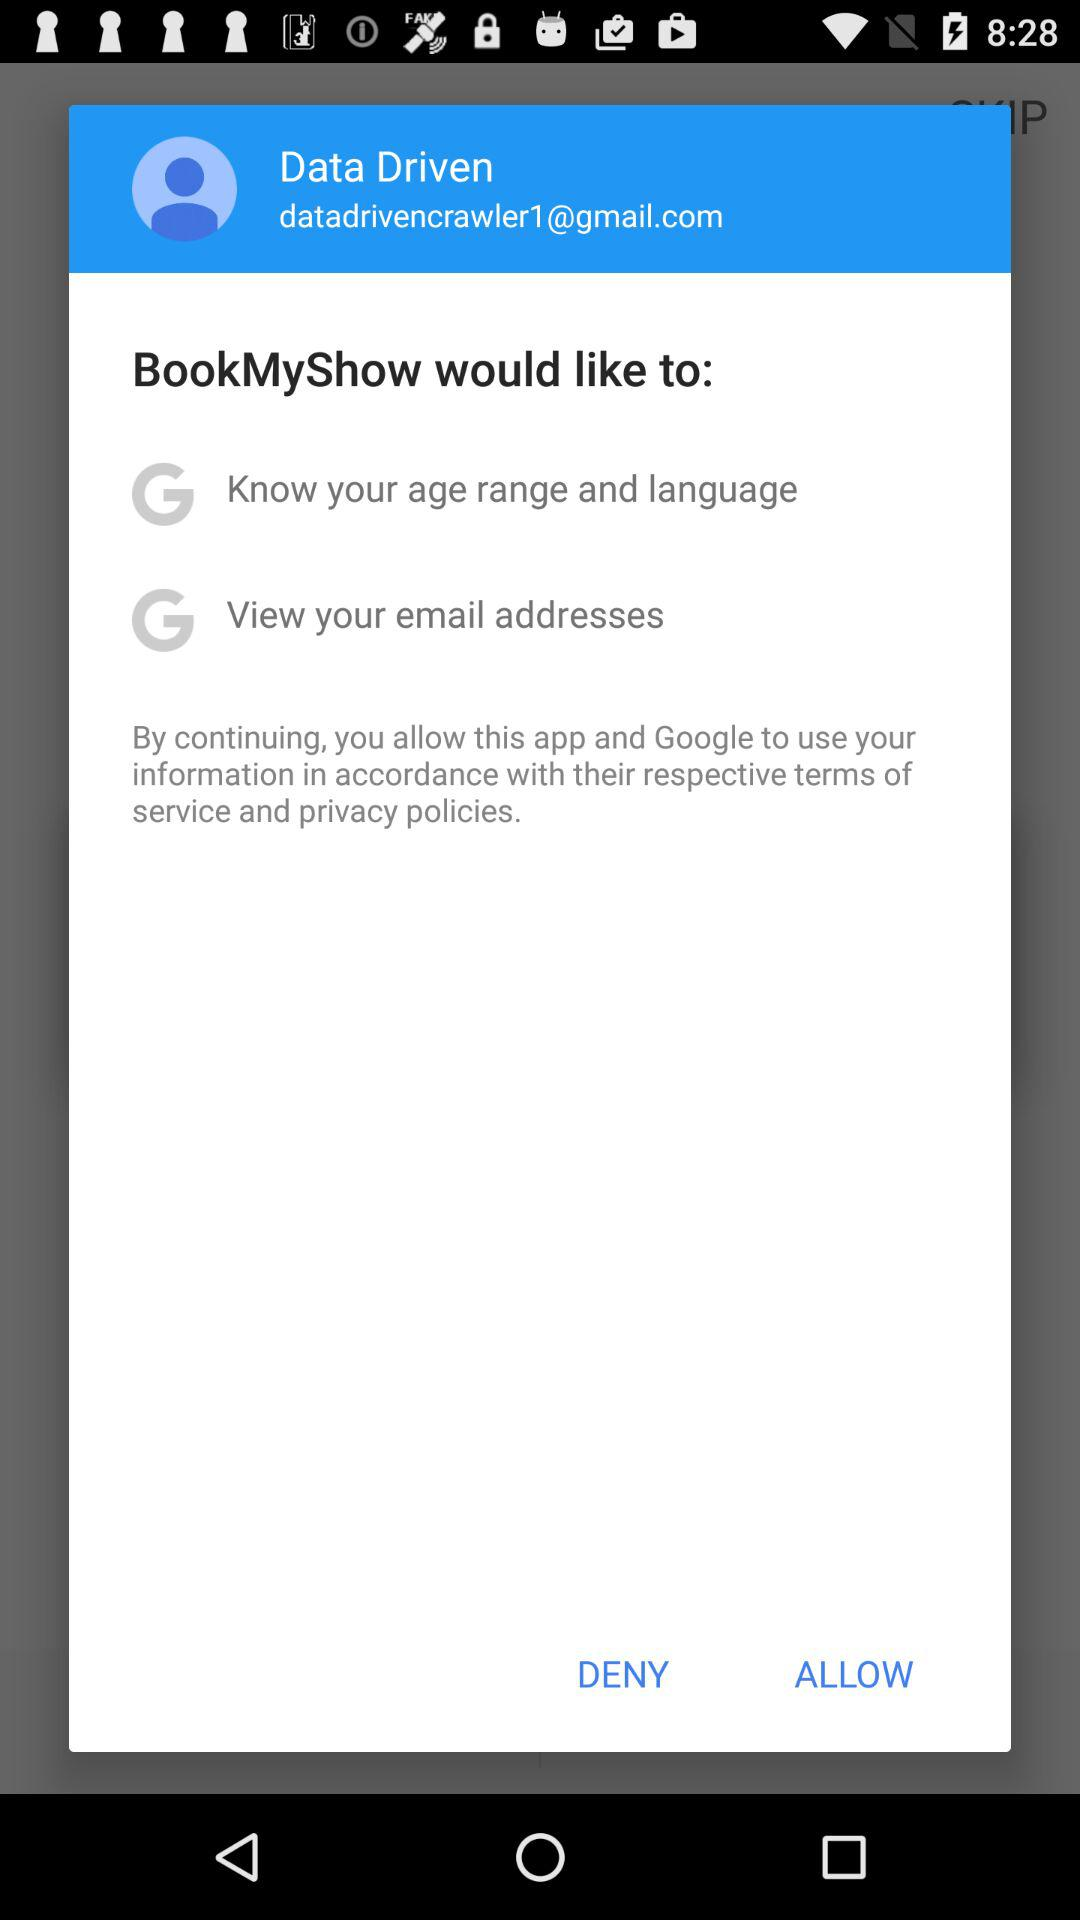What is the user name? The user name is Data Driven. 